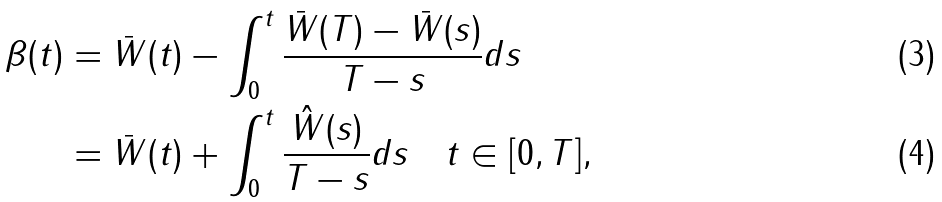Convert formula to latex. <formula><loc_0><loc_0><loc_500><loc_500>\beta ( t ) & = \bar { W } ( t ) - \int _ { 0 } ^ { t } \frac { \bar { W } ( T ) - \bar { W } ( s ) } { T - s } d s \\ & = \bar { W } ( t ) + \int _ { 0 } ^ { t } \frac { \hat { W } ( s ) } { T - s } d s \quad t \in [ 0 , T ] ,</formula> 